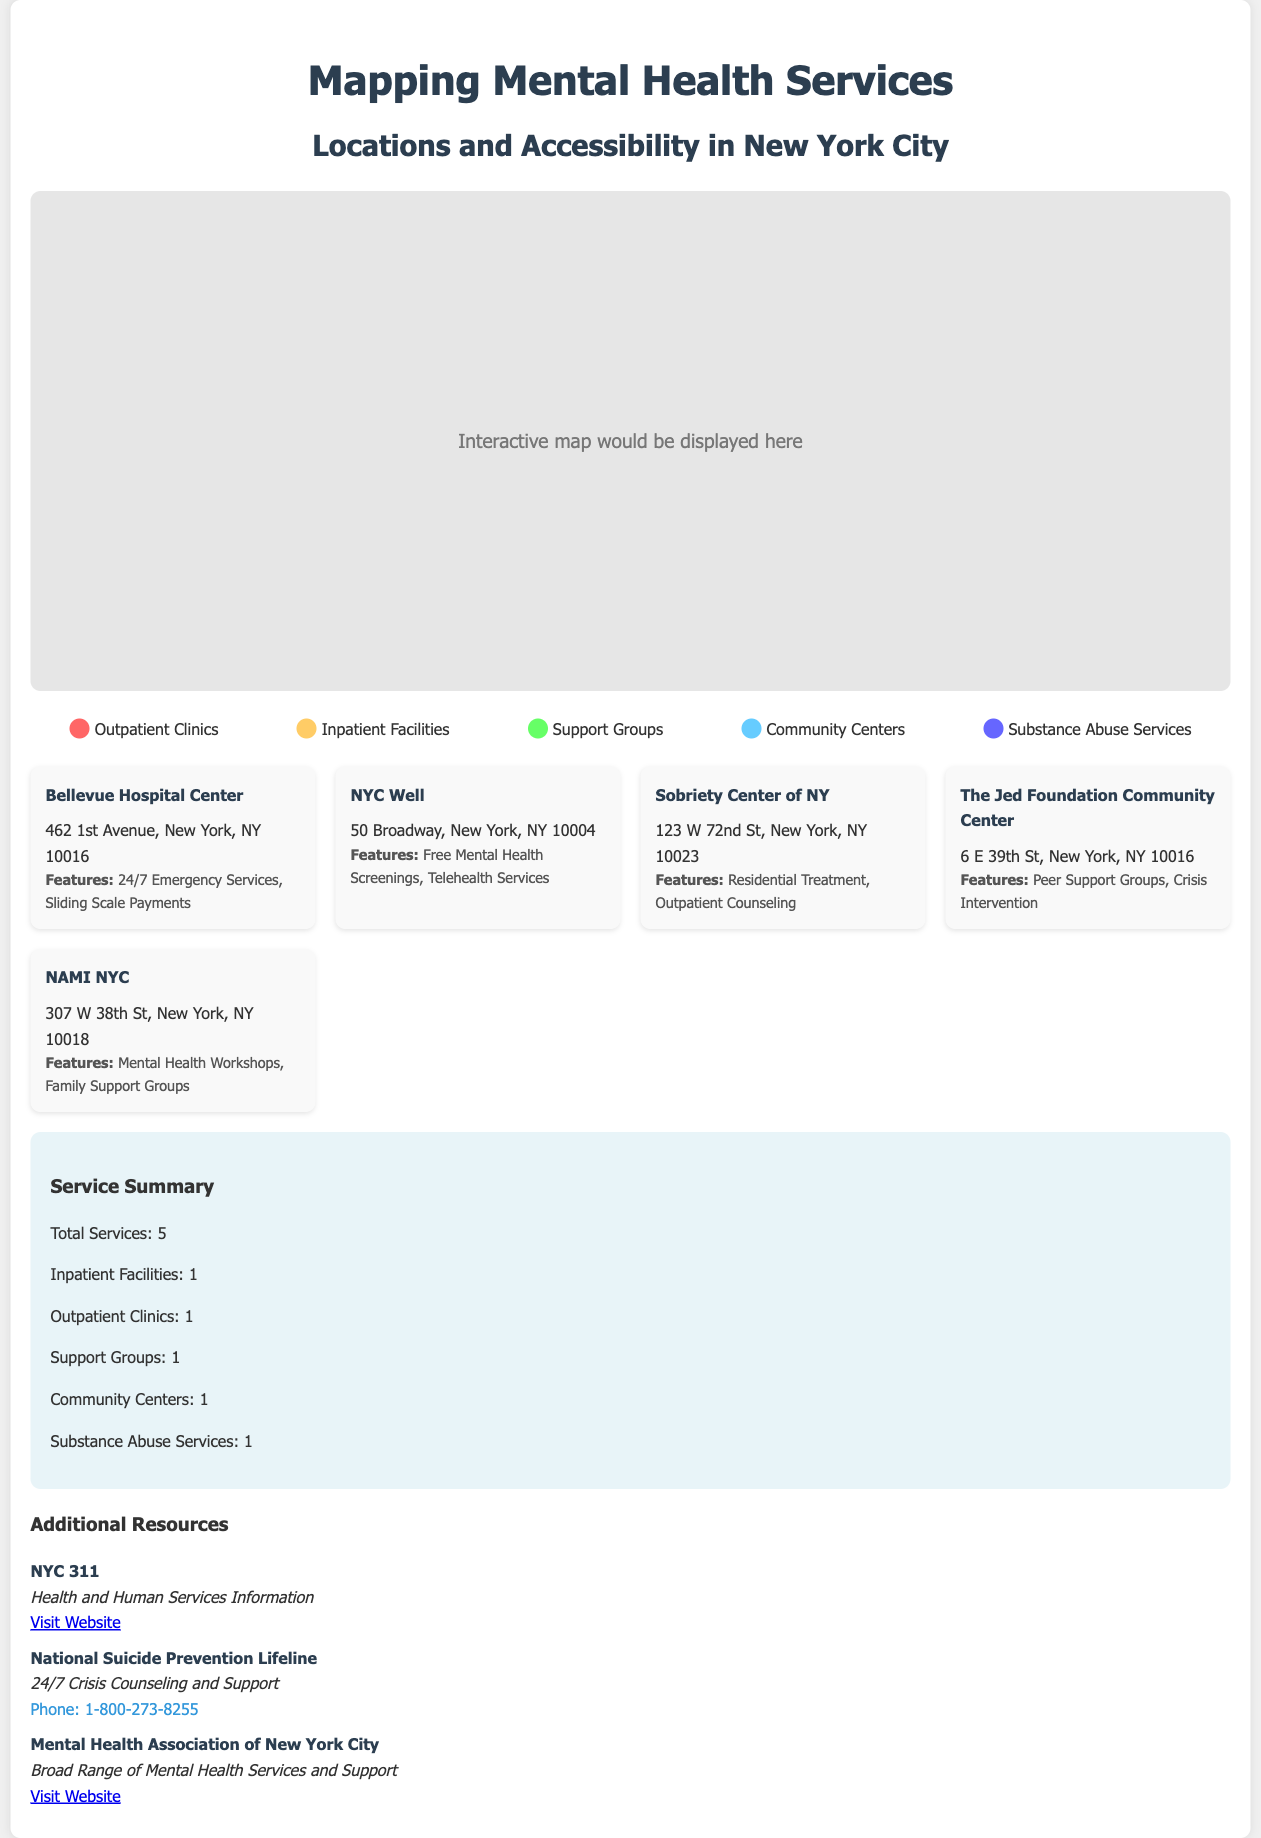What is the title of the document? The title is displayed prominently at the top of the document and provides a clear indication of the content.
Answer: Mapping Mental Health Services How many total services are listed? The total number of services is summarized in the service summary section and can be found easily.
Answer: 5 What type of service does Bellevue Hospital Center provide? The information about the services provided at Bellevue Hospital Center is mentioned directly under its name.
Answer: Outpatient Clinics What is one feature of NYC Well? The features of NYC Well are outlined, and it's possible to pick one specific feature mentioned.
Answer: Free Mental Health Screenings Where is the Sobriety Center of NY located? The address for Sobriety Center of NY is explicitly presented in the location card for that service.
Answer: 123 W 72nd St, New York, NY 10023 What color represents Support Groups in the legend? The legend section visually indicates the color associated with different types of services.
Answer: Green Which organization provides 24/7 Crisis Counseling and Support? The resource list contains contact information for an organization that provides this service.
Answer: National Suicide Prevention Lifeline How many Community Centers are listed? The summary section contains a breakdown of the types of services including Community Centers.
Answer: 1 What type of service is provided by NAMI NYC? The type of services offered by NAMI NYC can be found in the specific location card.
Answer: Support Groups 